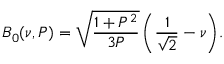<formula> <loc_0><loc_0><loc_500><loc_500>B _ { 0 } ( \nu , P ) = \sqrt { \frac { 1 + P ^ { 2 } } { 3 P } } \, \left ( \frac { 1 } { \sqrt { 2 } } - \nu \right ) .</formula> 